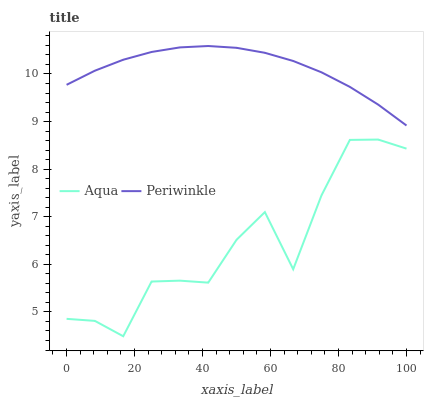Does Aqua have the minimum area under the curve?
Answer yes or no. Yes. Does Periwinkle have the maximum area under the curve?
Answer yes or no. Yes. Does Aqua have the maximum area under the curve?
Answer yes or no. No. Is Periwinkle the smoothest?
Answer yes or no. Yes. Is Aqua the roughest?
Answer yes or no. Yes. Is Aqua the smoothest?
Answer yes or no. No. Does Periwinkle have the highest value?
Answer yes or no. Yes. Does Aqua have the highest value?
Answer yes or no. No. Is Aqua less than Periwinkle?
Answer yes or no. Yes. Is Periwinkle greater than Aqua?
Answer yes or no. Yes. Does Aqua intersect Periwinkle?
Answer yes or no. No. 